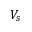Convert formula to latex. <formula><loc_0><loc_0><loc_500><loc_500>V _ { s }</formula> 